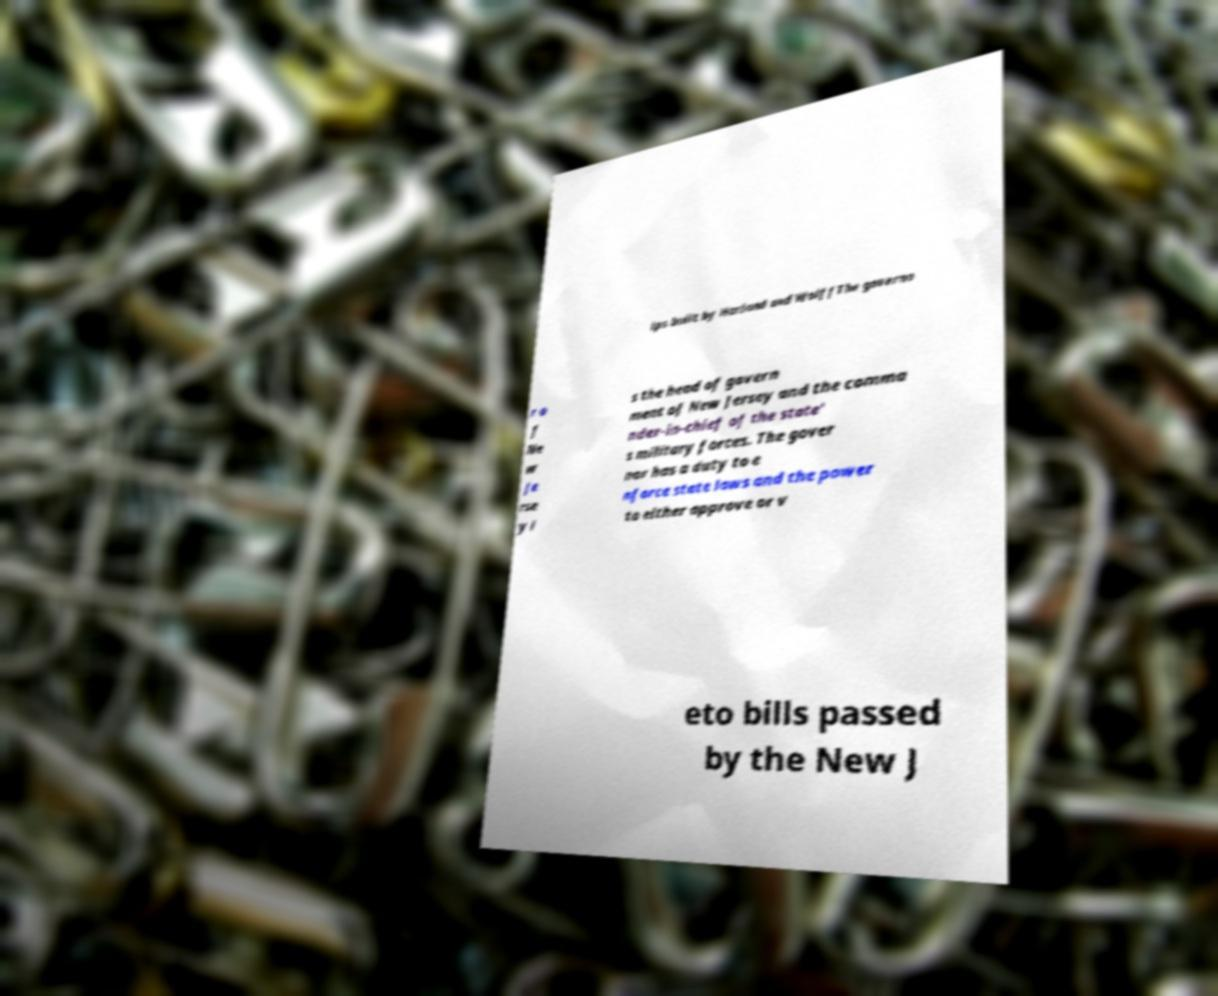Please read and relay the text visible in this image. What does it say? ips built by Harland and WolffThe governo r o f Ne w Je rse y i s the head of govern ment of New Jersey and the comma nder-in-chief of the state' s military forces. The gover nor has a duty to e nforce state laws and the power to either approve or v eto bills passed by the New J 